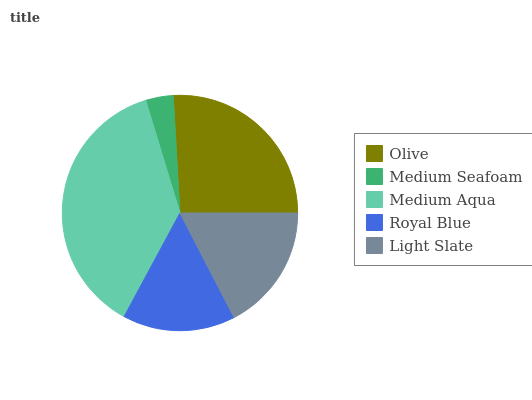Is Medium Seafoam the minimum?
Answer yes or no. Yes. Is Medium Aqua the maximum?
Answer yes or no. Yes. Is Medium Aqua the minimum?
Answer yes or no. No. Is Medium Seafoam the maximum?
Answer yes or no. No. Is Medium Aqua greater than Medium Seafoam?
Answer yes or no. Yes. Is Medium Seafoam less than Medium Aqua?
Answer yes or no. Yes. Is Medium Seafoam greater than Medium Aqua?
Answer yes or no. No. Is Medium Aqua less than Medium Seafoam?
Answer yes or no. No. Is Light Slate the high median?
Answer yes or no. Yes. Is Light Slate the low median?
Answer yes or no. Yes. Is Medium Seafoam the high median?
Answer yes or no. No. Is Olive the low median?
Answer yes or no. No. 